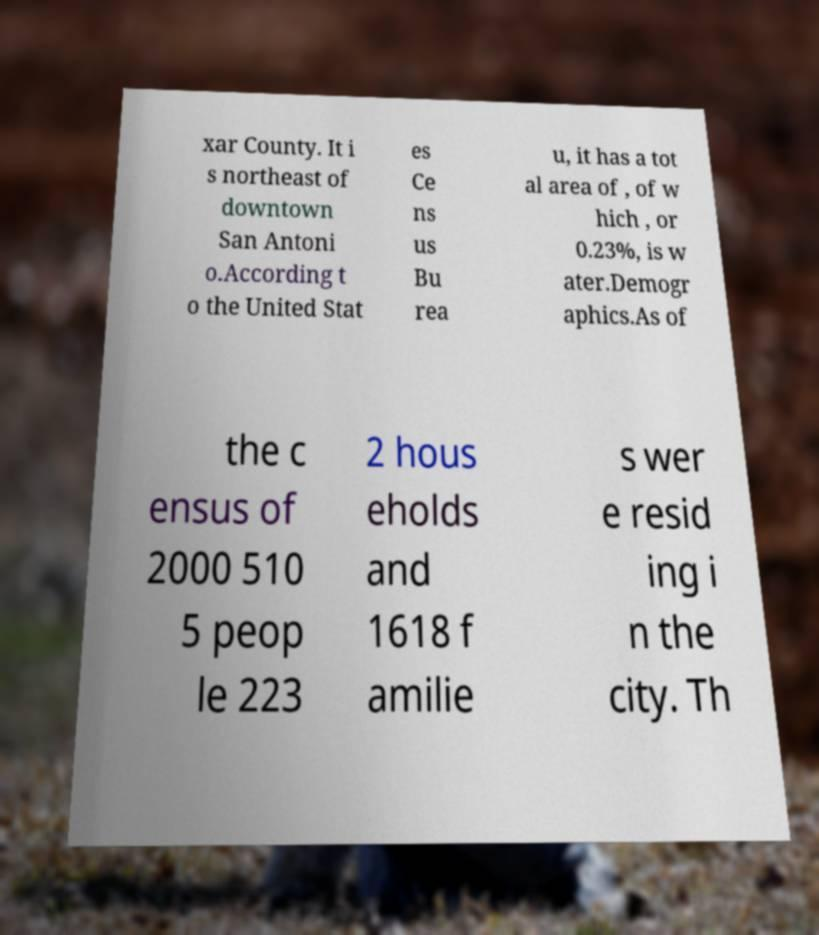Can you accurately transcribe the text from the provided image for me? xar County. It i s northeast of downtown San Antoni o.According t o the United Stat es Ce ns us Bu rea u, it has a tot al area of , of w hich , or 0.23%, is w ater.Demogr aphics.As of the c ensus of 2000 510 5 peop le 223 2 hous eholds and 1618 f amilie s wer e resid ing i n the city. Th 